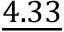Convert formula to latex. <formula><loc_0><loc_0><loc_500><loc_500>\underline { 4 . 3 3 }</formula> 